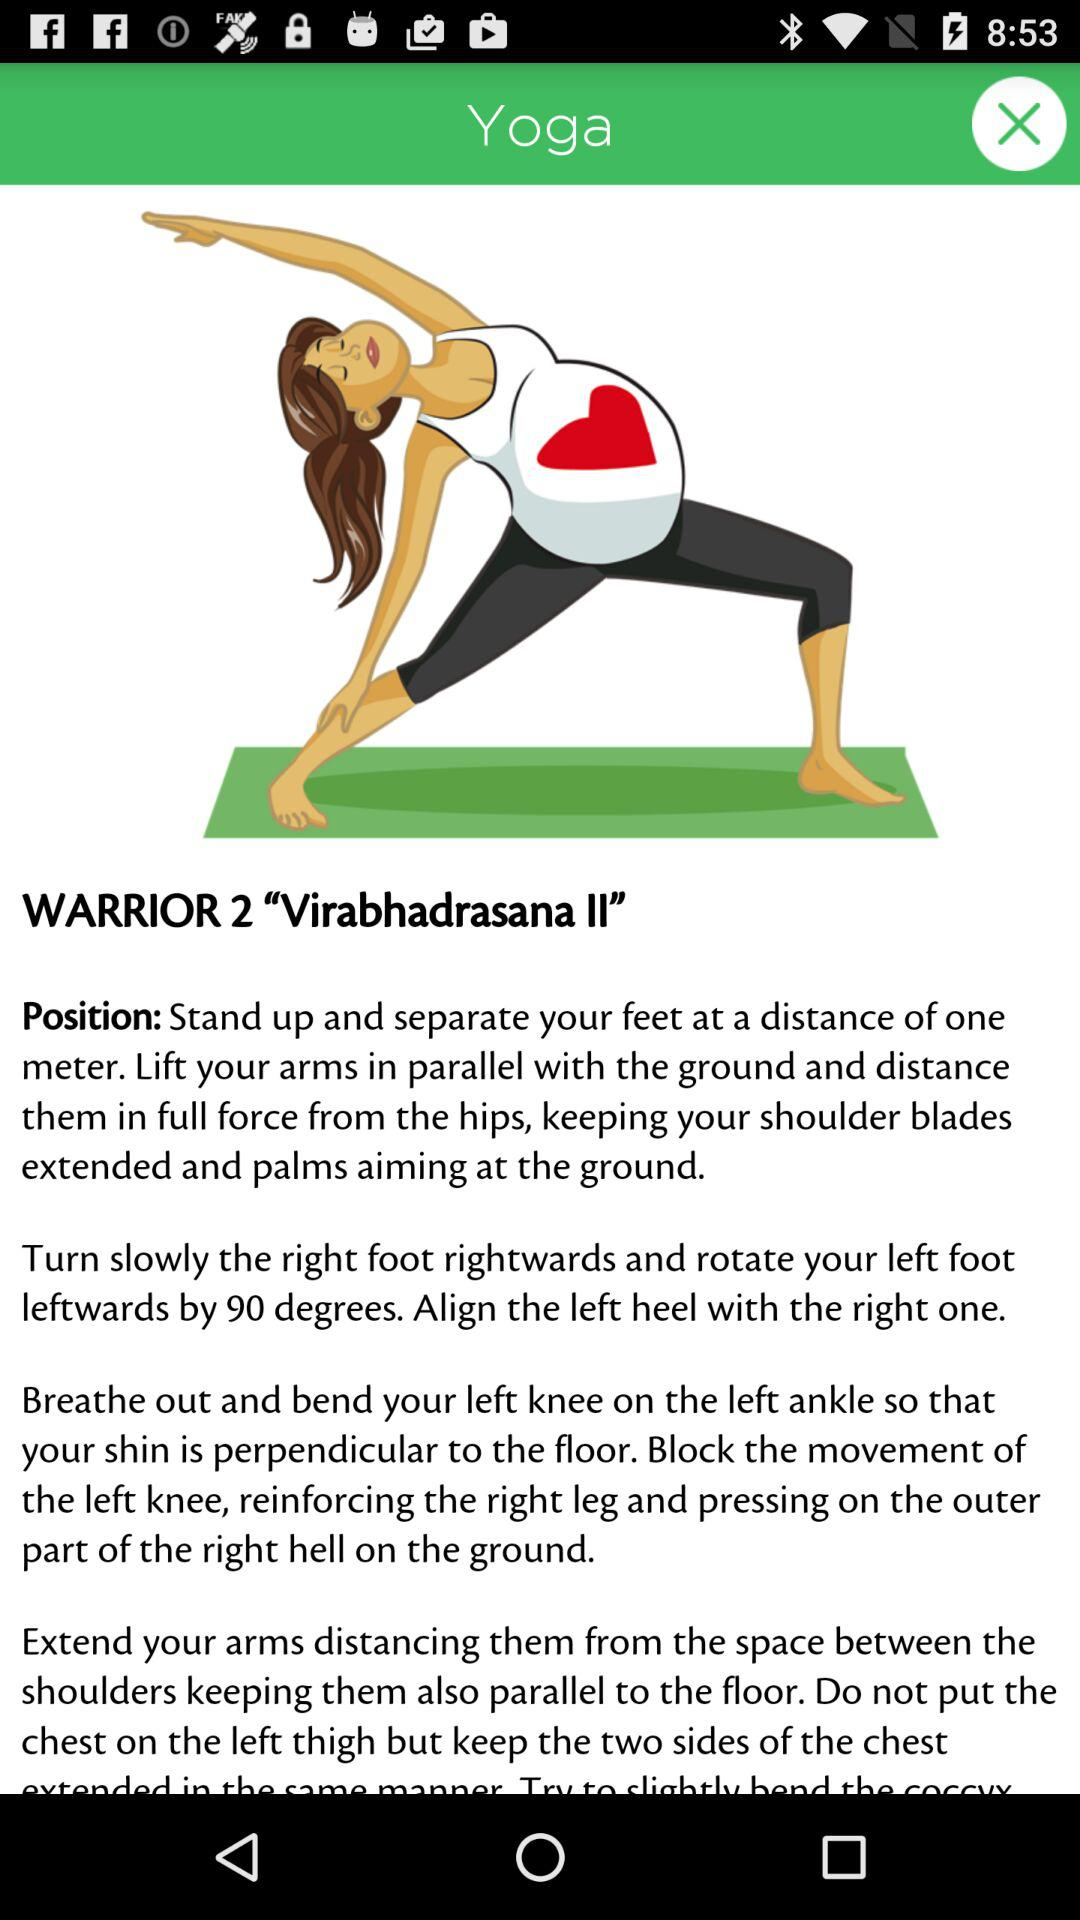How many instructions are there for the Warrior 2 pose?
Answer the question using a single word or phrase. 4 